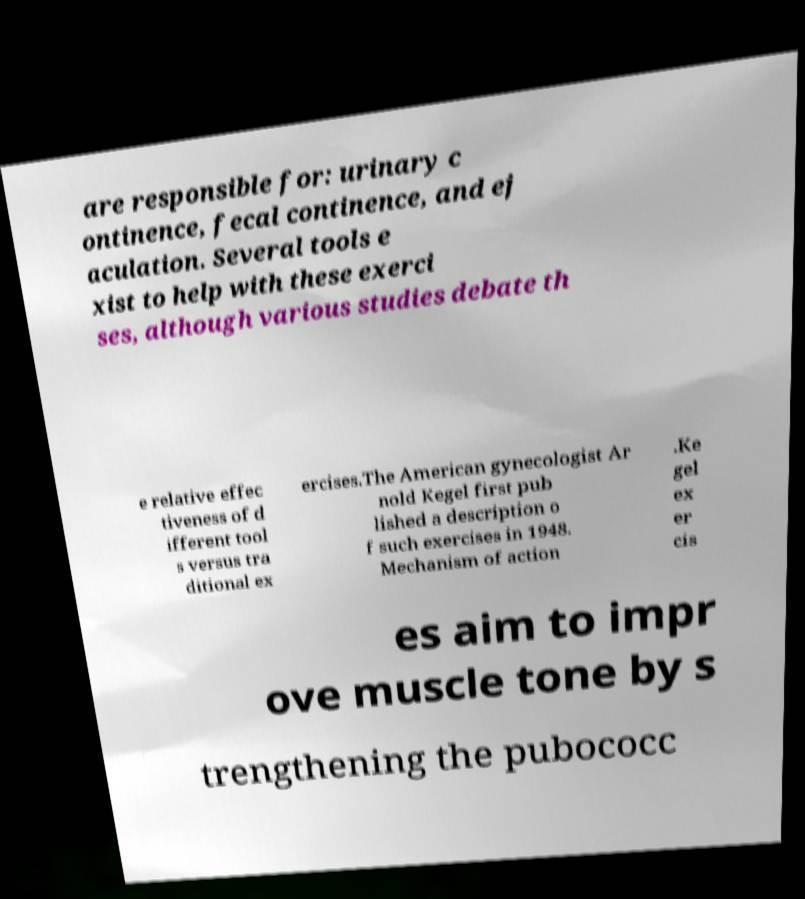Could you assist in decoding the text presented in this image and type it out clearly? are responsible for: urinary c ontinence, fecal continence, and ej aculation. Several tools e xist to help with these exerci ses, although various studies debate th e relative effec tiveness of d ifferent tool s versus tra ditional ex ercises.The American gynecologist Ar nold Kegel first pub lished a description o f such exercises in 1948. Mechanism of action .Ke gel ex er cis es aim to impr ove muscle tone by s trengthening the pubococc 